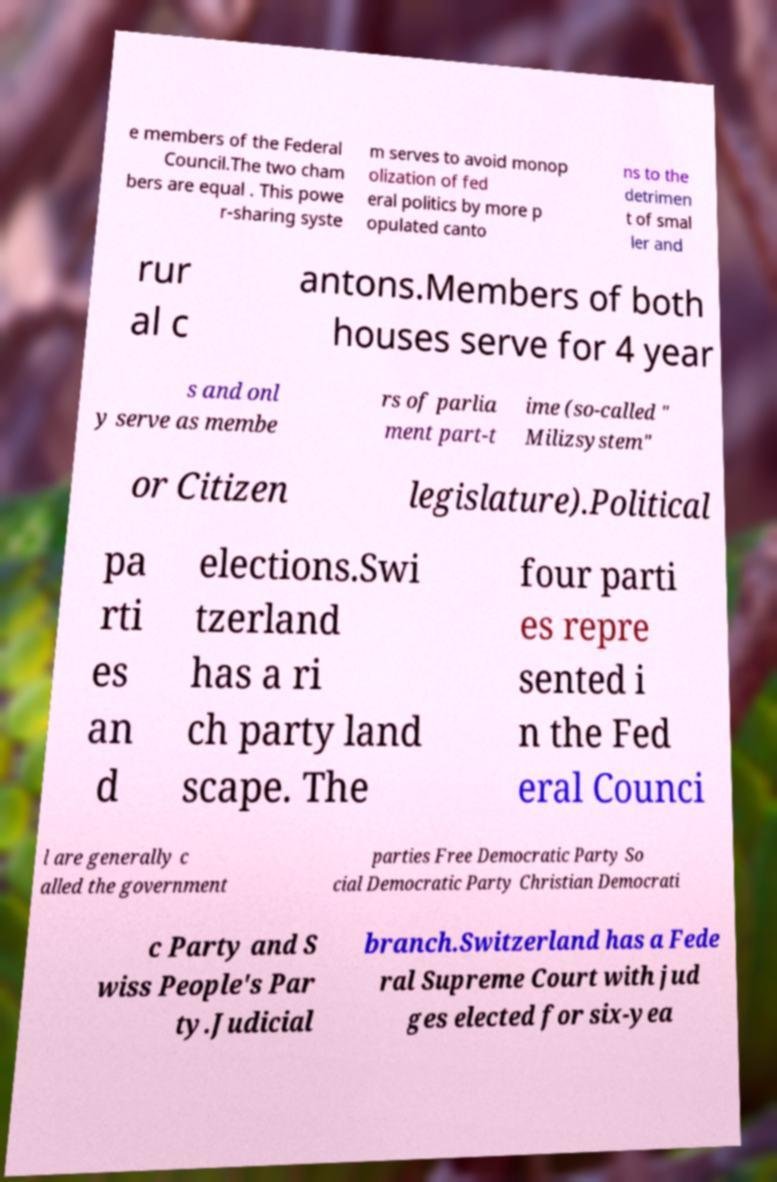For documentation purposes, I need the text within this image transcribed. Could you provide that? e members of the Federal Council.The two cham bers are equal . This powe r-sharing syste m serves to avoid monop olization of fed eral politics by more p opulated canto ns to the detrimen t of smal ler and rur al c antons.Members of both houses serve for 4 year s and onl y serve as membe rs of parlia ment part-t ime (so-called " Milizsystem" or Citizen legislature).Political pa rti es an d elections.Swi tzerland has a ri ch party land scape. The four parti es repre sented i n the Fed eral Counci l are generally c alled the government parties Free Democratic Party So cial Democratic Party Christian Democrati c Party and S wiss People's Par ty.Judicial branch.Switzerland has a Fede ral Supreme Court with jud ges elected for six-yea 